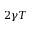<formula> <loc_0><loc_0><loc_500><loc_500>2 \gamma T</formula> 